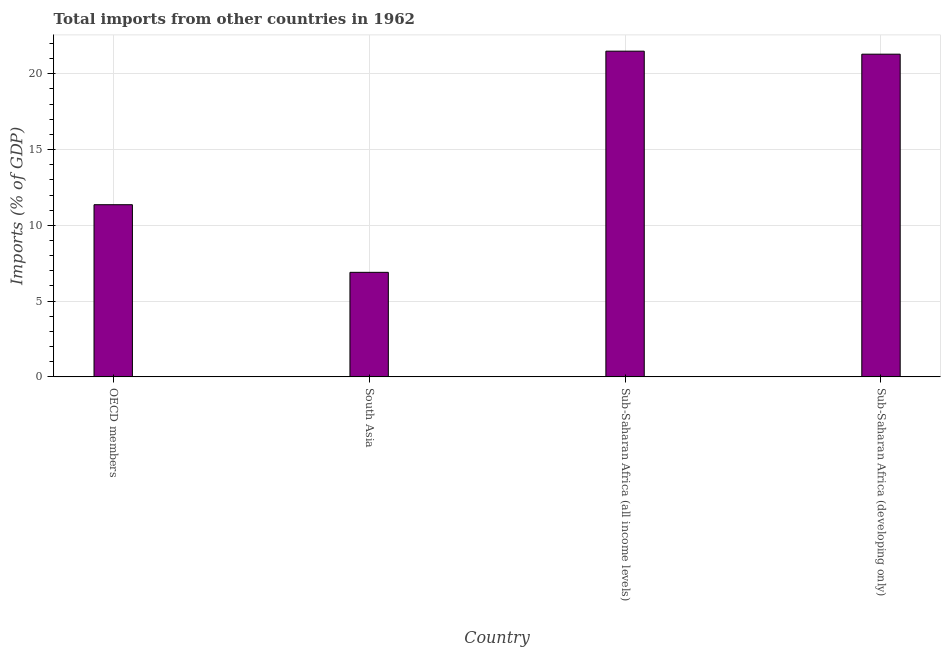Does the graph contain any zero values?
Offer a terse response. No. Does the graph contain grids?
Ensure brevity in your answer.  Yes. What is the title of the graph?
Provide a short and direct response. Total imports from other countries in 1962. What is the label or title of the X-axis?
Ensure brevity in your answer.  Country. What is the label or title of the Y-axis?
Give a very brief answer. Imports (% of GDP). What is the total imports in South Asia?
Offer a terse response. 6.9. Across all countries, what is the maximum total imports?
Your answer should be very brief. 21.49. Across all countries, what is the minimum total imports?
Make the answer very short. 6.9. In which country was the total imports maximum?
Provide a succinct answer. Sub-Saharan Africa (all income levels). What is the sum of the total imports?
Offer a very short reply. 61.04. What is the difference between the total imports in OECD members and Sub-Saharan Africa (all income levels)?
Provide a short and direct response. -10.13. What is the average total imports per country?
Your answer should be compact. 15.26. What is the median total imports?
Make the answer very short. 16.33. In how many countries, is the total imports greater than 18 %?
Your answer should be compact. 2. What is the ratio of the total imports in South Asia to that in Sub-Saharan Africa (developing only)?
Ensure brevity in your answer.  0.32. What is the difference between the highest and the second highest total imports?
Your answer should be very brief. 0.2. Is the sum of the total imports in OECD members and Sub-Saharan Africa (developing only) greater than the maximum total imports across all countries?
Your response must be concise. Yes. What is the difference between the highest and the lowest total imports?
Offer a very short reply. 14.59. In how many countries, is the total imports greater than the average total imports taken over all countries?
Keep it short and to the point. 2. How many bars are there?
Your response must be concise. 4. Are all the bars in the graph horizontal?
Your answer should be compact. No. Are the values on the major ticks of Y-axis written in scientific E-notation?
Give a very brief answer. No. What is the Imports (% of GDP) in OECD members?
Offer a very short reply. 11.36. What is the Imports (% of GDP) in South Asia?
Give a very brief answer. 6.9. What is the Imports (% of GDP) in Sub-Saharan Africa (all income levels)?
Provide a succinct answer. 21.49. What is the Imports (% of GDP) of Sub-Saharan Africa (developing only)?
Make the answer very short. 21.29. What is the difference between the Imports (% of GDP) in OECD members and South Asia?
Offer a terse response. 4.46. What is the difference between the Imports (% of GDP) in OECD members and Sub-Saharan Africa (all income levels)?
Offer a terse response. -10.13. What is the difference between the Imports (% of GDP) in OECD members and Sub-Saharan Africa (developing only)?
Ensure brevity in your answer.  -9.93. What is the difference between the Imports (% of GDP) in South Asia and Sub-Saharan Africa (all income levels)?
Your answer should be very brief. -14.59. What is the difference between the Imports (% of GDP) in South Asia and Sub-Saharan Africa (developing only)?
Keep it short and to the point. -14.39. What is the difference between the Imports (% of GDP) in Sub-Saharan Africa (all income levels) and Sub-Saharan Africa (developing only)?
Make the answer very short. 0.2. What is the ratio of the Imports (% of GDP) in OECD members to that in South Asia?
Provide a short and direct response. 1.65. What is the ratio of the Imports (% of GDP) in OECD members to that in Sub-Saharan Africa (all income levels)?
Give a very brief answer. 0.53. What is the ratio of the Imports (% of GDP) in OECD members to that in Sub-Saharan Africa (developing only)?
Ensure brevity in your answer.  0.53. What is the ratio of the Imports (% of GDP) in South Asia to that in Sub-Saharan Africa (all income levels)?
Give a very brief answer. 0.32. What is the ratio of the Imports (% of GDP) in South Asia to that in Sub-Saharan Africa (developing only)?
Keep it short and to the point. 0.32. What is the ratio of the Imports (% of GDP) in Sub-Saharan Africa (all income levels) to that in Sub-Saharan Africa (developing only)?
Ensure brevity in your answer.  1.01. 